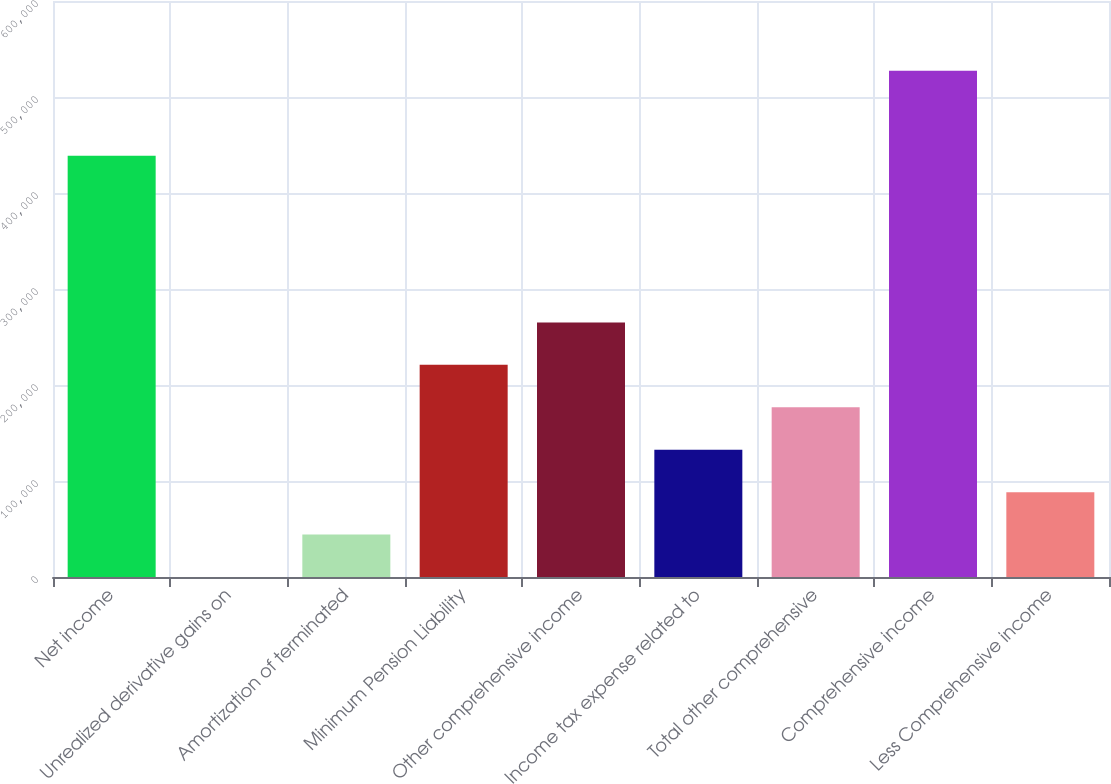Convert chart. <chart><loc_0><loc_0><loc_500><loc_500><bar_chart><fcel>Net income<fcel>Unrealized derivative gains on<fcel>Amortization of terminated<fcel>Minimum Pension Liability<fcel>Other comprehensive income<fcel>Income tax expense related to<fcel>Total other comprehensive<fcel>Comprehensive income<fcel>Less Comprehensive income<nl><fcel>438873<fcel>0.69<fcel>44196.7<fcel>220981<fcel>265177<fcel>132589<fcel>176785<fcel>527265<fcel>88392.8<nl></chart> 